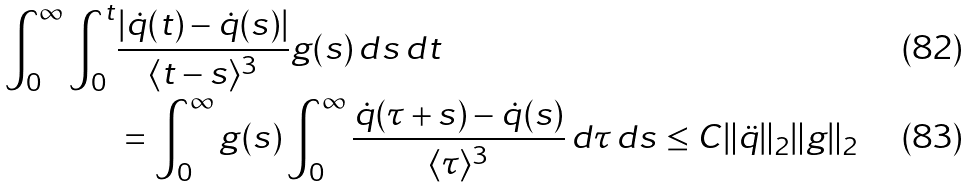<formula> <loc_0><loc_0><loc_500><loc_500>\, \int _ { 0 } ^ { \infty } \int _ { 0 } ^ { t } & \frac { | \dot { q } ( t ) - \dot { q } ( s ) | } { \langle t - s \rangle ^ { 3 } } g ( s ) \, d s \, d t \\ & = \int _ { 0 } ^ { \infty } g ( s ) \int _ { 0 } ^ { \infty } \frac { \dot { q } ( \tau + s ) - \dot { q } ( s ) } { \langle \tau \rangle ^ { 3 } } \, d \tau \, d s \leq C \| \ddot { q } \| _ { 2 } \| g \| _ { 2 }</formula> 